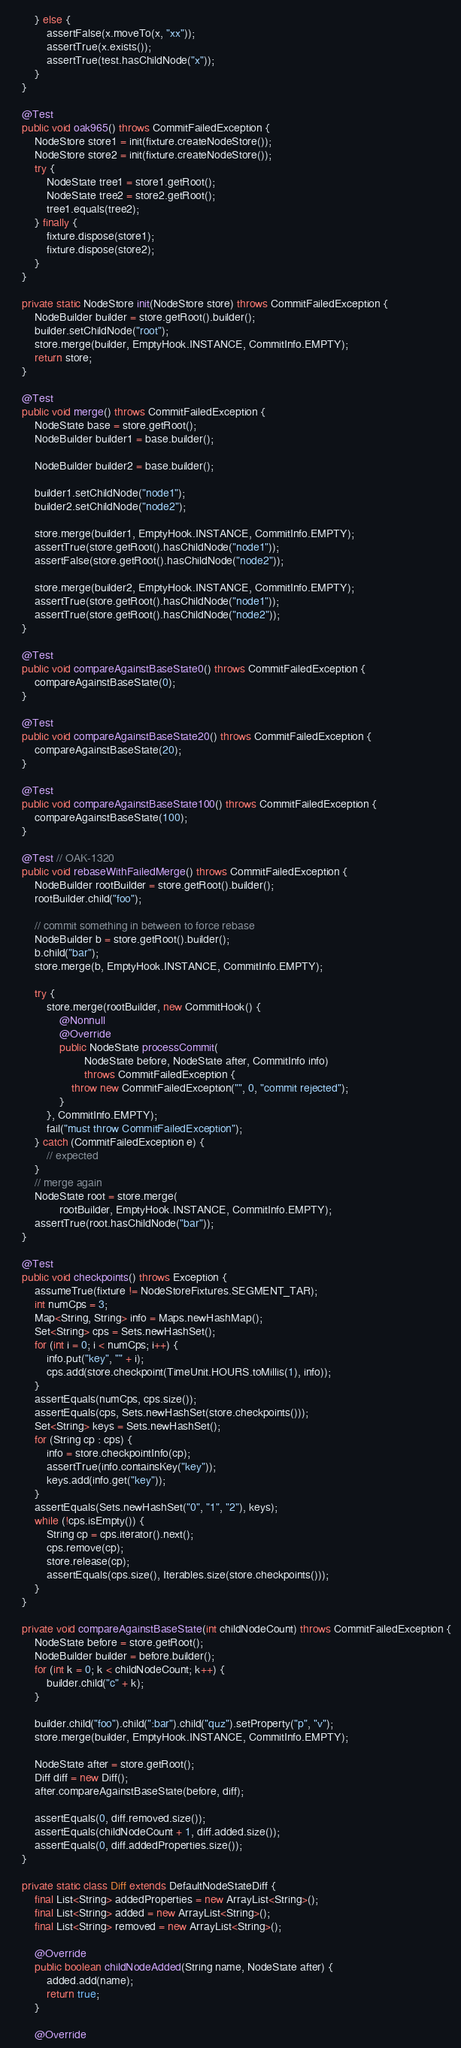<code> <loc_0><loc_0><loc_500><loc_500><_Java_>        } else {
            assertFalse(x.moveTo(x, "xx"));
            assertTrue(x.exists());
            assertTrue(test.hasChildNode("x"));
        }
    }

    @Test
    public void oak965() throws CommitFailedException {
        NodeStore store1 = init(fixture.createNodeStore());
        NodeStore store2 = init(fixture.createNodeStore());
        try {
            NodeState tree1 = store1.getRoot();
            NodeState tree2 = store2.getRoot();
            tree1.equals(tree2);
        } finally {
            fixture.dispose(store1);
            fixture.dispose(store2);
        }
    }

    private static NodeStore init(NodeStore store) throws CommitFailedException {
        NodeBuilder builder = store.getRoot().builder();
        builder.setChildNode("root");
        store.merge(builder, EmptyHook.INSTANCE, CommitInfo.EMPTY);
        return store;
    }

    @Test
    public void merge() throws CommitFailedException {
        NodeState base = store.getRoot();
        NodeBuilder builder1 = base.builder();

        NodeBuilder builder2 = base.builder();

        builder1.setChildNode("node1");
        builder2.setChildNode("node2");

        store.merge(builder1, EmptyHook.INSTANCE, CommitInfo.EMPTY);
        assertTrue(store.getRoot().hasChildNode("node1"));
        assertFalse(store.getRoot().hasChildNode("node2"));

        store.merge(builder2, EmptyHook.INSTANCE, CommitInfo.EMPTY);
        assertTrue(store.getRoot().hasChildNode("node1"));
        assertTrue(store.getRoot().hasChildNode("node2"));
    }

    @Test
    public void compareAgainstBaseState0() throws CommitFailedException {
        compareAgainstBaseState(0);
    }

    @Test
    public void compareAgainstBaseState20() throws CommitFailedException {
        compareAgainstBaseState(20);
    }

    @Test
    public void compareAgainstBaseState100() throws CommitFailedException {
        compareAgainstBaseState(100);
    }

    @Test // OAK-1320
    public void rebaseWithFailedMerge() throws CommitFailedException {
        NodeBuilder rootBuilder = store.getRoot().builder();
        rootBuilder.child("foo");

        // commit something in between to force rebase
        NodeBuilder b = store.getRoot().builder();
        b.child("bar");
        store.merge(b, EmptyHook.INSTANCE, CommitInfo.EMPTY);

        try {
            store.merge(rootBuilder, new CommitHook() {
                @Nonnull
                @Override
                public NodeState processCommit(
                        NodeState before, NodeState after, CommitInfo info)
                        throws CommitFailedException {
                    throw new CommitFailedException("", 0, "commit rejected");
                }
            }, CommitInfo.EMPTY);
            fail("must throw CommitFailedException");
        } catch (CommitFailedException e) {
            // expected
        }
        // merge again
        NodeState root = store.merge(
                rootBuilder, EmptyHook.INSTANCE, CommitInfo.EMPTY);
        assertTrue(root.hasChildNode("bar"));
    }

    @Test
    public void checkpoints() throws Exception {
        assumeTrue(fixture != NodeStoreFixtures.SEGMENT_TAR);
        int numCps = 3;
        Map<String, String> info = Maps.newHashMap();
        Set<String> cps = Sets.newHashSet();
        for (int i = 0; i < numCps; i++) {
            info.put("key", "" + i);
            cps.add(store.checkpoint(TimeUnit.HOURS.toMillis(1), info));
        }
        assertEquals(numCps, cps.size());
        assertEquals(cps, Sets.newHashSet(store.checkpoints()));
        Set<String> keys = Sets.newHashSet();
        for (String cp : cps) {
            info = store.checkpointInfo(cp);
            assertTrue(info.containsKey("key"));
            keys.add(info.get("key"));
        }
        assertEquals(Sets.newHashSet("0", "1", "2"), keys);
        while (!cps.isEmpty()) {
            String cp = cps.iterator().next();
            cps.remove(cp);
            store.release(cp);
            assertEquals(cps.size(), Iterables.size(store.checkpoints()));
        }
    }

    private void compareAgainstBaseState(int childNodeCount) throws CommitFailedException {
        NodeState before = store.getRoot();
        NodeBuilder builder = before.builder();
        for (int k = 0; k < childNodeCount; k++) {
            builder.child("c" + k);
        }

        builder.child("foo").child(":bar").child("quz").setProperty("p", "v");
        store.merge(builder, EmptyHook.INSTANCE, CommitInfo.EMPTY);

        NodeState after = store.getRoot();
        Diff diff = new Diff();
        after.compareAgainstBaseState(before, diff);

        assertEquals(0, diff.removed.size());
        assertEquals(childNodeCount + 1, diff.added.size());
        assertEquals(0, diff.addedProperties.size());
    }

    private static class Diff extends DefaultNodeStateDiff {
        final List<String> addedProperties = new ArrayList<String>();
        final List<String> added = new ArrayList<String>();
        final List<String> removed = new ArrayList<String>();

        @Override
        public boolean childNodeAdded(String name, NodeState after) {
            added.add(name);
            return true;
        }

        @Override</code> 